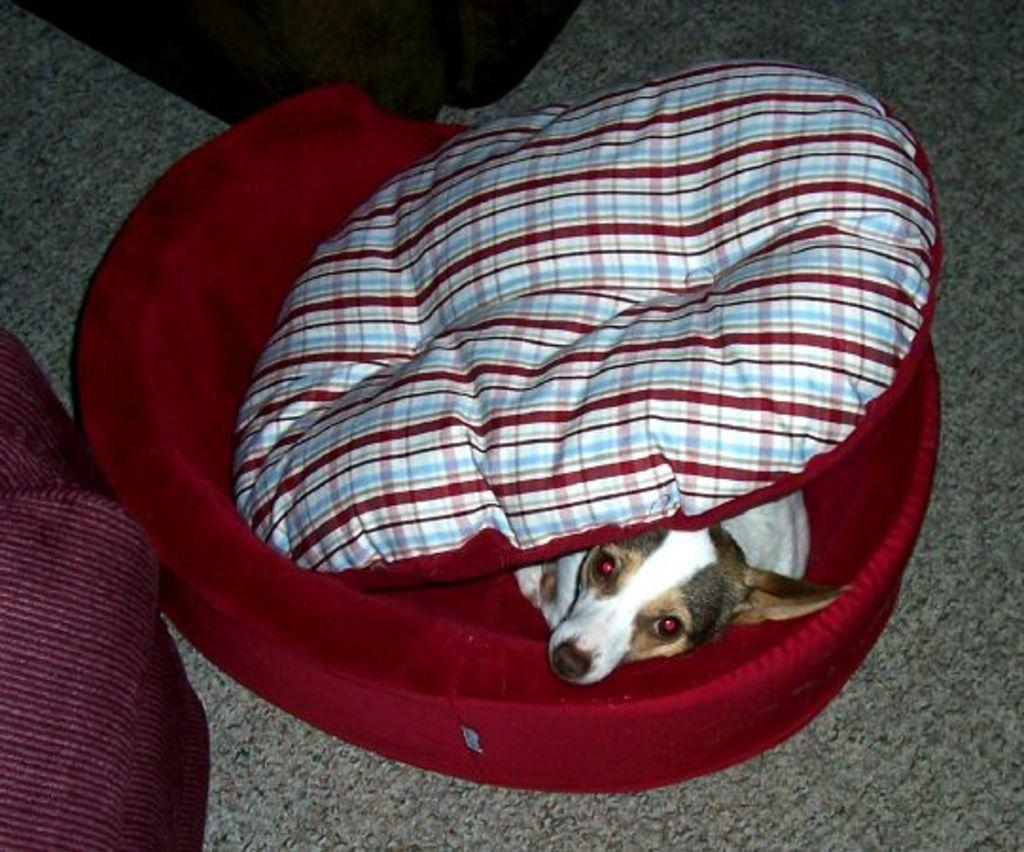What type of animal is in the image? There is a dog in the image. What is the dog doing in the image? The dog is sleeping. Where is the dog located in the image? The dog is on a small bed. What is on the bed with the dog? There is a pillow on the bed. Where is the bed placed in the image? The bed is on the floor. What type of drum can be seen in the image? There is no drum present in the image; it features a dog sleeping on a small bed. How many bags are visible in the image? There are no bags visible in the image. 